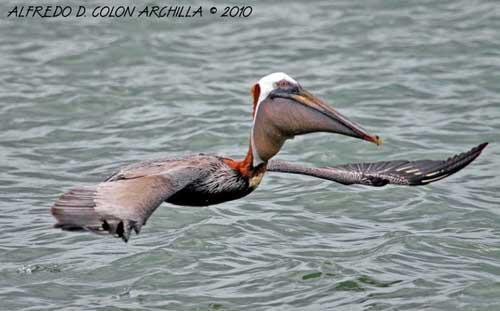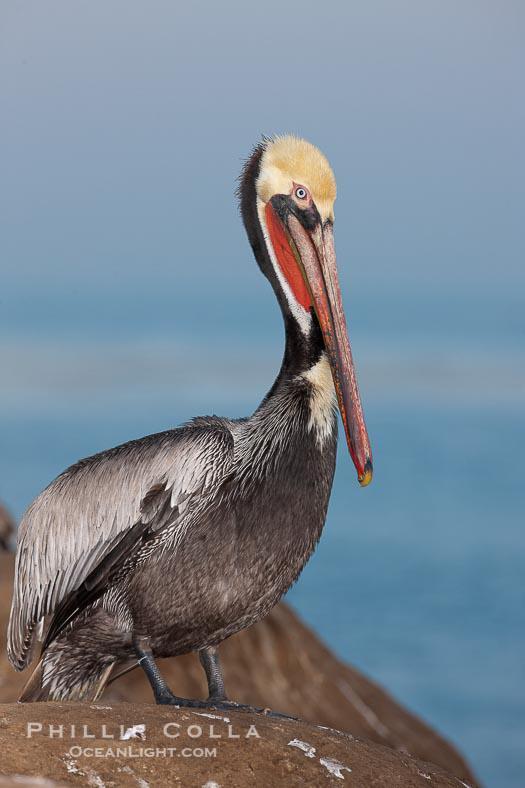The first image is the image on the left, the second image is the image on the right. Given the left and right images, does the statement "The bird in the right image is facing towards the left." hold true? Answer yes or no. No. The first image is the image on the left, the second image is the image on the right. Analyze the images presented: Is the assertion "A single bird is flying over the water in the image on the left." valid? Answer yes or no. Yes. 